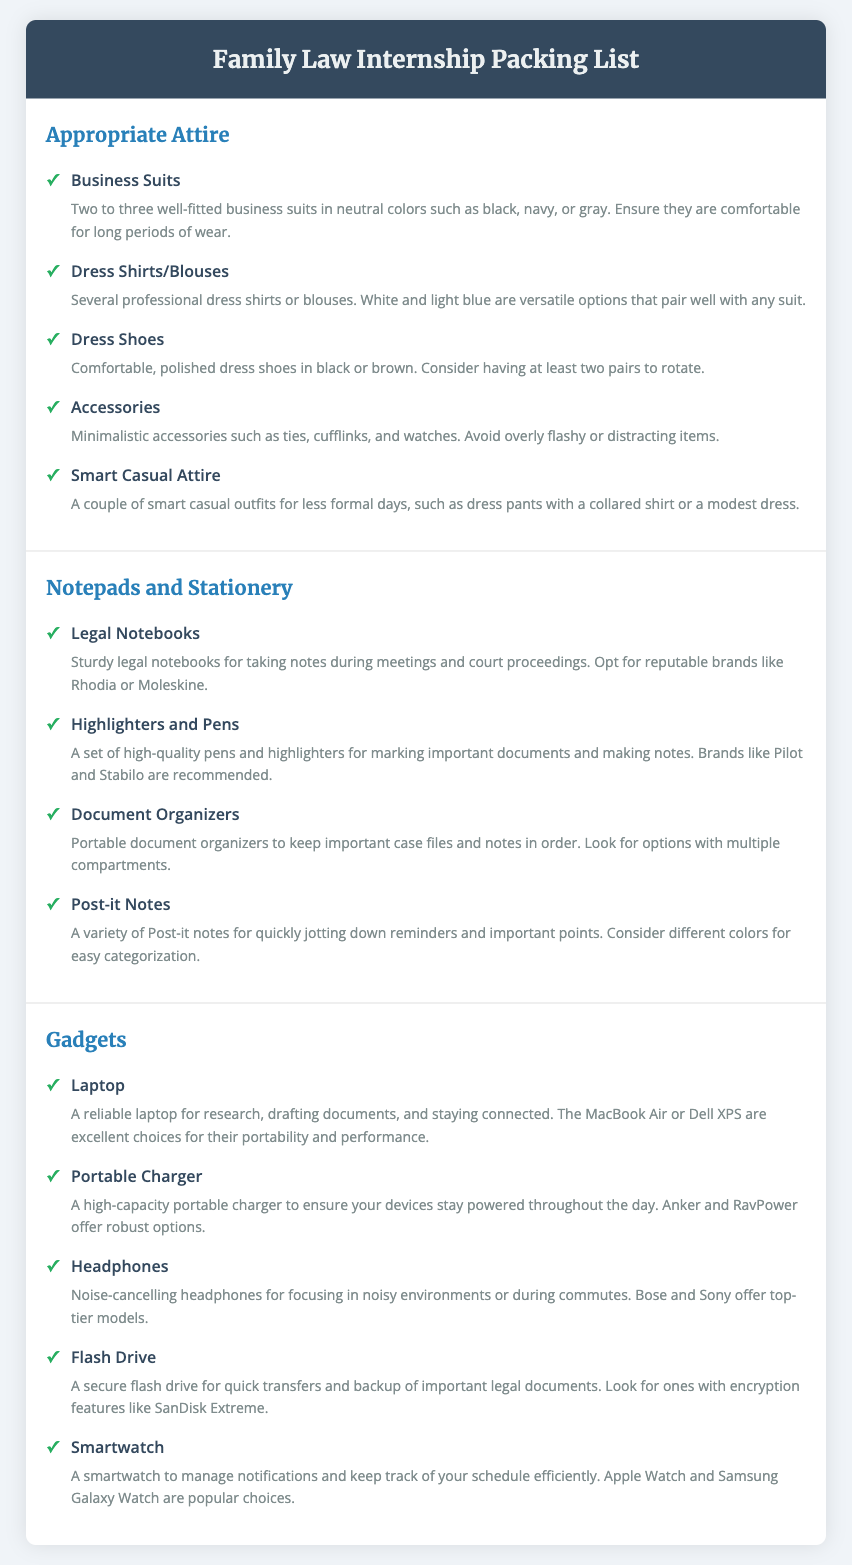What types of outfits are recommended for the internship? The document lists business suits, dress shirts/blouses, smart casual attire, and accessories as recommended outfits for the internship.
Answer: Business suits, dress shirts/blouses, smart casual attire, accessories How many pairs of dress shoes should an intern consider bringing? The document suggests bringing at least two pairs of dress shoes to rotate, emphasizing comfort and polish.
Answer: Two pairs What is a recommended brand for legal notebooks? The document mentions reputable brands like Rhodia or Moleskine for legal notebooks.
Answer: Rhodia, Moleskine What type of charger is necessary for the internship? The document specifies a high-capacity portable charger to keep devices powered throughout the day.
Answer: High-capacity portable charger Which item is suggested for quickly jotting down reminders? Post-it notes are recommended for quickly jotting down reminders and important points.
Answer: Post-it notes What is the purpose of a document organizer mentioned in the packing list? The document organizer is designed to keep important case files and notes in order with multiple compartments.
Answer: Keeping important case files and notes in order What type of headphones are preferred for the internship? Noise-cancelling headphones are preferred for focusing in noisy environments or during commutes.
Answer: Noise-cancelling headphones How many business suits are advised to bring? The document advises bringing two to three well-fitted business suits.
Answer: Two to three 